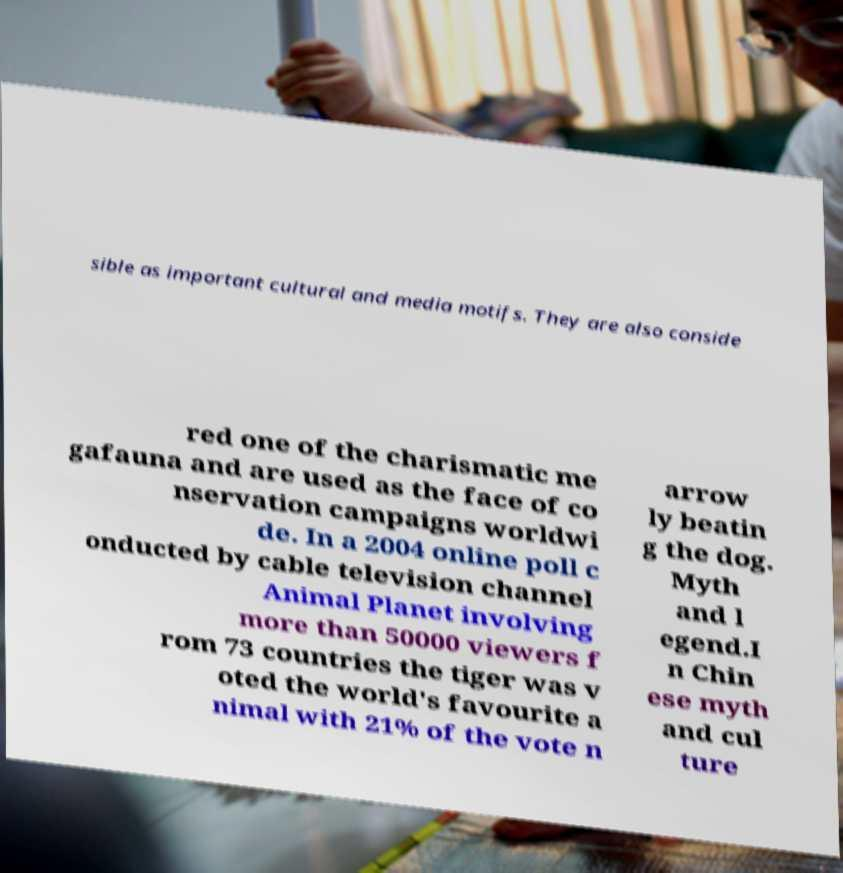Can you read and provide the text displayed in the image?This photo seems to have some interesting text. Can you extract and type it out for me? sible as important cultural and media motifs. They are also conside red one of the charismatic me gafauna and are used as the face of co nservation campaigns worldwi de. In a 2004 online poll c onducted by cable television channel Animal Planet involving more than 50000 viewers f rom 73 countries the tiger was v oted the world's favourite a nimal with 21% of the vote n arrow ly beatin g the dog. Myth and l egend.I n Chin ese myth and cul ture 